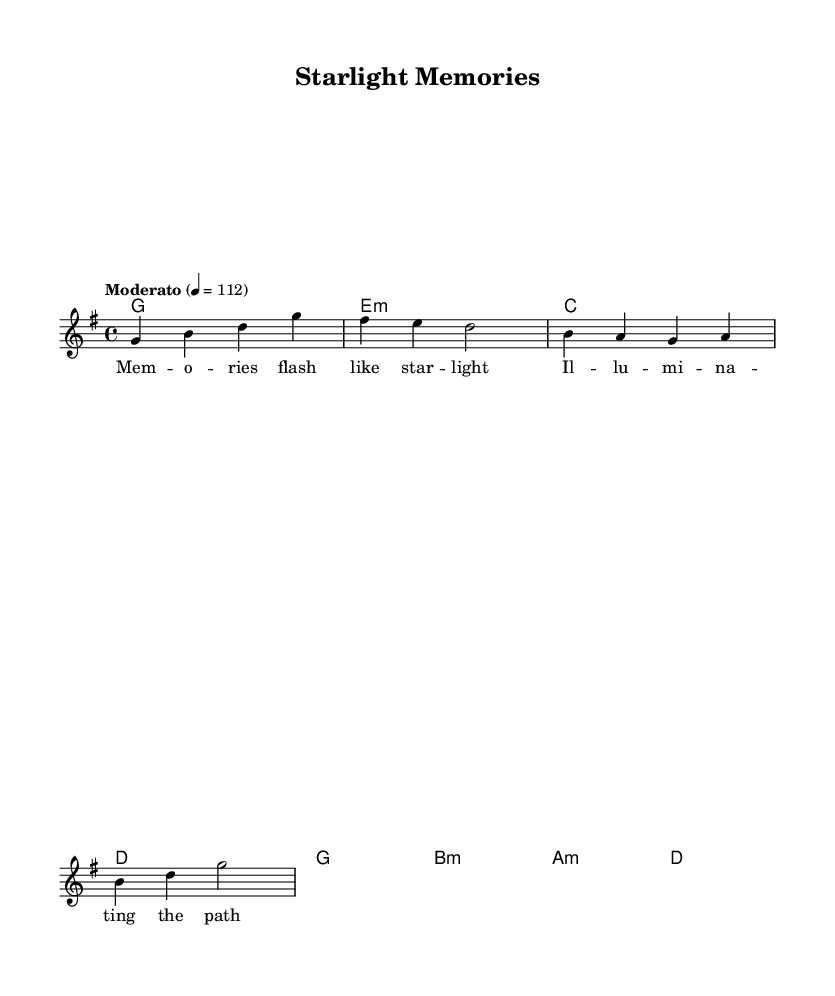What is the key signature of this music? The key signature is G major, which has one sharp (F#). This can be identified by looking at the key signature shown at the beginning of the staff, indicating G major.
Answer: G major What is the time signature of this music? The time signature is 4/4, which means there are four beats per measure and the quarter note gets one beat. This is indicated directly beneath the clef at the start of the score.
Answer: 4/4 What is the tempo marking of this piece? The tempo marking is "Moderato" with a metronome marking of 112 beats per minute. This is noted in the tempo indication above the staff.
Answer: Moderato How many measures are in the melody? The melody consists of four measures, which can be counted by looking at the bar lines separating the sections in the sheet music.
Answer: 4 What is the tonic chord in the harmony section? The tonic chord is G major, as it is the first chord listed in the chord progression for the piece. Chord progressions typically start with the tonic, which is G in this case due to the key signature identified earlier.
Answer: G What is the lyrical theme of this piece? The lyrical theme reflects on memories and their illuminating quality, as indicated by the lyrics themselves which mention "Memories flash like starlight." This theme often resonates within the biopic context, emphasizing nostalgia and reflection.
Answer: Memories Which musical mode is primarily used in this piece? The piece is written in a major mode, specifically G major, which can be inferred from both the key signature and the overall brightness of the chords, commonly associated with major modes in contemporary music.
Answer: Major 